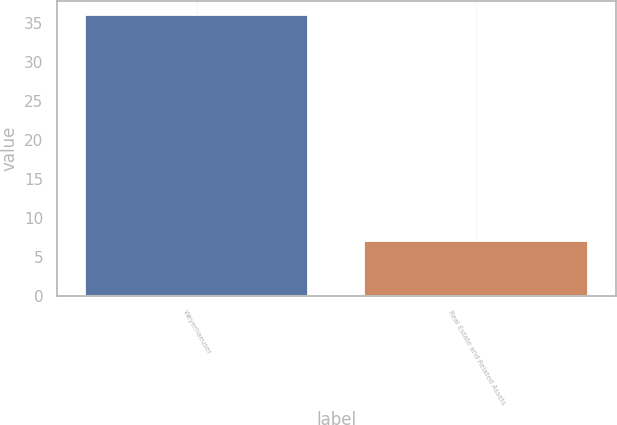Convert chart to OTSL. <chart><loc_0><loc_0><loc_500><loc_500><bar_chart><fcel>Weyerhaeuser<fcel>Real Estate and Related Assets<nl><fcel>36<fcel>7<nl></chart> 